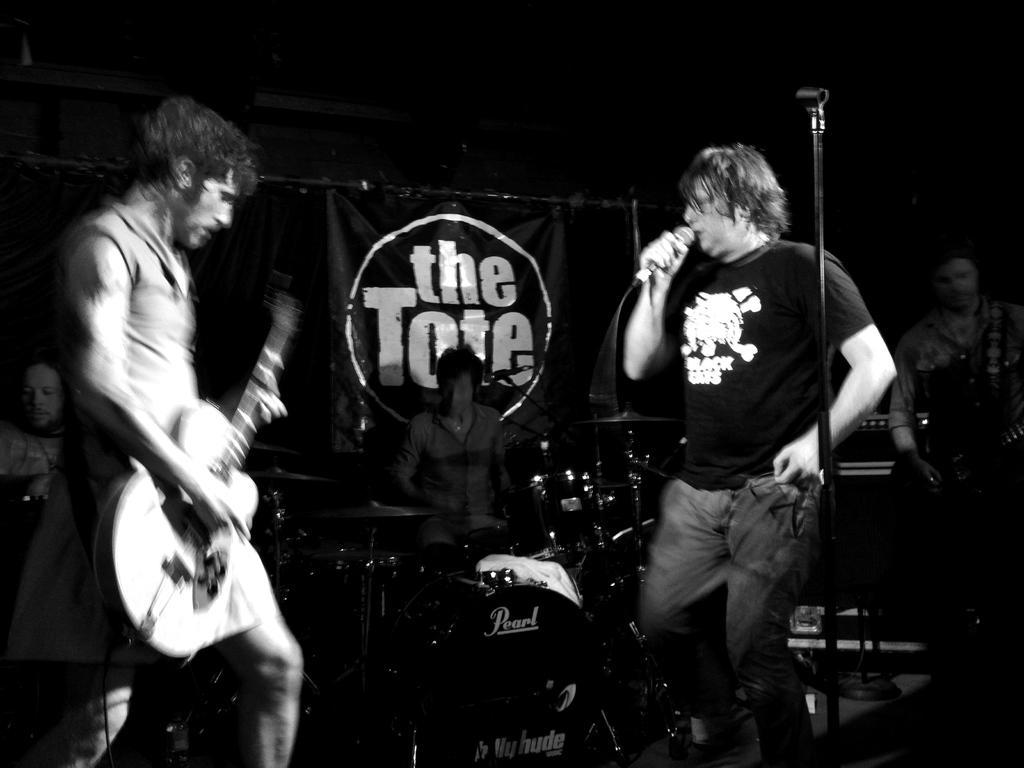Could you give a brief overview of what you see in this image? In this picture there are group of people those who are singing and playing the guitars there is a person who is sitting at the center of the image is playing the drums, the color of the background is black in color and the person who is standing at the left side of the image is holding the guitar. 